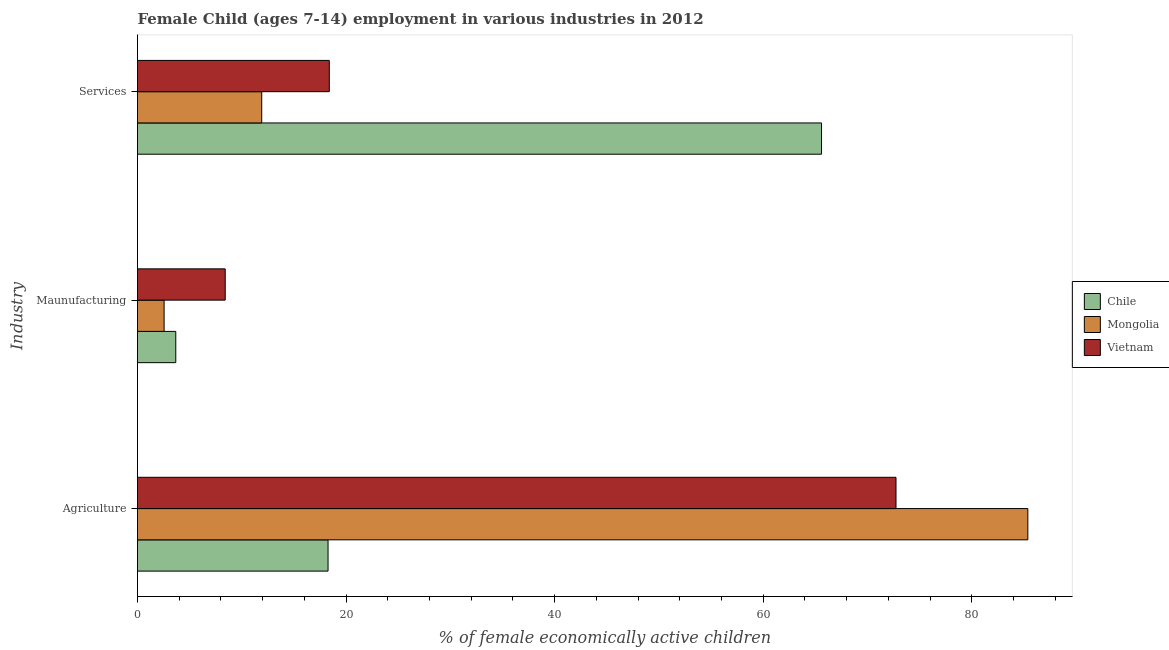How many groups of bars are there?
Offer a terse response. 3. Are the number of bars per tick equal to the number of legend labels?
Your response must be concise. Yes. Are the number of bars on each tick of the Y-axis equal?
Offer a terse response. Yes. What is the label of the 1st group of bars from the top?
Provide a short and direct response. Services. What is the percentage of economically active children in agriculture in Vietnam?
Provide a short and direct response. 72.73. Across all countries, what is the maximum percentage of economically active children in services?
Give a very brief answer. 65.59. Across all countries, what is the minimum percentage of economically active children in services?
Provide a succinct answer. 11.91. In which country was the percentage of economically active children in agriculture maximum?
Offer a terse response. Mongolia. In which country was the percentage of economically active children in services minimum?
Keep it short and to the point. Mongolia. What is the total percentage of economically active children in agriculture in the graph?
Keep it short and to the point. 176.37. What is the difference between the percentage of economically active children in services in Vietnam and that in Chile?
Keep it short and to the point. -47.2. What is the difference between the percentage of economically active children in manufacturing in Mongolia and the percentage of economically active children in services in Chile?
Your response must be concise. -63.04. What is the average percentage of economically active children in agriculture per country?
Your answer should be compact. 58.79. What is the difference between the percentage of economically active children in agriculture and percentage of economically active children in manufacturing in Vietnam?
Your answer should be very brief. 64.32. In how many countries, is the percentage of economically active children in agriculture greater than 44 %?
Ensure brevity in your answer.  2. What is the ratio of the percentage of economically active children in manufacturing in Vietnam to that in Mongolia?
Offer a terse response. 3.3. Is the difference between the percentage of economically active children in manufacturing in Mongolia and Vietnam greater than the difference between the percentage of economically active children in services in Mongolia and Vietnam?
Give a very brief answer. Yes. What is the difference between the highest and the second highest percentage of economically active children in services?
Keep it short and to the point. 47.2. What is the difference between the highest and the lowest percentage of economically active children in manufacturing?
Ensure brevity in your answer.  5.86. What does the 1st bar from the top in Maunufacturing represents?
Give a very brief answer. Vietnam. What does the 3rd bar from the bottom in Maunufacturing represents?
Make the answer very short. Vietnam. Is it the case that in every country, the sum of the percentage of economically active children in agriculture and percentage of economically active children in manufacturing is greater than the percentage of economically active children in services?
Offer a terse response. No. How many bars are there?
Make the answer very short. 9. Are all the bars in the graph horizontal?
Provide a short and direct response. Yes. Are the values on the major ticks of X-axis written in scientific E-notation?
Ensure brevity in your answer.  No. How many legend labels are there?
Provide a short and direct response. 3. How are the legend labels stacked?
Offer a terse response. Vertical. What is the title of the graph?
Your answer should be compact. Female Child (ages 7-14) employment in various industries in 2012. Does "Arab World" appear as one of the legend labels in the graph?
Your answer should be compact. No. What is the label or title of the X-axis?
Offer a terse response. % of female economically active children. What is the label or title of the Y-axis?
Your answer should be very brief. Industry. What is the % of female economically active children of Chile in Agriculture?
Your answer should be very brief. 18.27. What is the % of female economically active children of Mongolia in Agriculture?
Provide a short and direct response. 85.37. What is the % of female economically active children in Vietnam in Agriculture?
Provide a succinct answer. 72.73. What is the % of female economically active children in Chile in Maunufacturing?
Your response must be concise. 3.67. What is the % of female economically active children in Mongolia in Maunufacturing?
Ensure brevity in your answer.  2.55. What is the % of female economically active children in Vietnam in Maunufacturing?
Provide a short and direct response. 8.41. What is the % of female economically active children in Chile in Services?
Your response must be concise. 65.59. What is the % of female economically active children of Mongolia in Services?
Give a very brief answer. 11.91. What is the % of female economically active children of Vietnam in Services?
Your answer should be very brief. 18.39. Across all Industry, what is the maximum % of female economically active children of Chile?
Ensure brevity in your answer.  65.59. Across all Industry, what is the maximum % of female economically active children in Mongolia?
Offer a very short reply. 85.37. Across all Industry, what is the maximum % of female economically active children of Vietnam?
Your answer should be very brief. 72.73. Across all Industry, what is the minimum % of female economically active children of Chile?
Offer a terse response. 3.67. Across all Industry, what is the minimum % of female economically active children in Mongolia?
Give a very brief answer. 2.55. Across all Industry, what is the minimum % of female economically active children in Vietnam?
Make the answer very short. 8.41. What is the total % of female economically active children of Chile in the graph?
Your answer should be very brief. 87.53. What is the total % of female economically active children in Mongolia in the graph?
Your answer should be compact. 99.83. What is the total % of female economically active children of Vietnam in the graph?
Your answer should be compact. 99.53. What is the difference between the % of female economically active children in Mongolia in Agriculture and that in Maunufacturing?
Ensure brevity in your answer.  82.82. What is the difference between the % of female economically active children in Vietnam in Agriculture and that in Maunufacturing?
Offer a very short reply. 64.32. What is the difference between the % of female economically active children in Chile in Agriculture and that in Services?
Offer a very short reply. -47.32. What is the difference between the % of female economically active children in Mongolia in Agriculture and that in Services?
Your answer should be compact. 73.46. What is the difference between the % of female economically active children of Vietnam in Agriculture and that in Services?
Your response must be concise. 54.34. What is the difference between the % of female economically active children of Chile in Maunufacturing and that in Services?
Keep it short and to the point. -61.92. What is the difference between the % of female economically active children in Mongolia in Maunufacturing and that in Services?
Offer a very short reply. -9.36. What is the difference between the % of female economically active children of Vietnam in Maunufacturing and that in Services?
Make the answer very short. -9.98. What is the difference between the % of female economically active children in Chile in Agriculture and the % of female economically active children in Mongolia in Maunufacturing?
Provide a short and direct response. 15.72. What is the difference between the % of female economically active children of Chile in Agriculture and the % of female economically active children of Vietnam in Maunufacturing?
Provide a short and direct response. 9.86. What is the difference between the % of female economically active children of Mongolia in Agriculture and the % of female economically active children of Vietnam in Maunufacturing?
Provide a short and direct response. 76.96. What is the difference between the % of female economically active children in Chile in Agriculture and the % of female economically active children in Mongolia in Services?
Ensure brevity in your answer.  6.36. What is the difference between the % of female economically active children of Chile in Agriculture and the % of female economically active children of Vietnam in Services?
Keep it short and to the point. -0.12. What is the difference between the % of female economically active children of Mongolia in Agriculture and the % of female economically active children of Vietnam in Services?
Your answer should be compact. 66.98. What is the difference between the % of female economically active children in Chile in Maunufacturing and the % of female economically active children in Mongolia in Services?
Provide a short and direct response. -8.24. What is the difference between the % of female economically active children of Chile in Maunufacturing and the % of female economically active children of Vietnam in Services?
Provide a short and direct response. -14.72. What is the difference between the % of female economically active children in Mongolia in Maunufacturing and the % of female economically active children in Vietnam in Services?
Your response must be concise. -15.84. What is the average % of female economically active children of Chile per Industry?
Offer a terse response. 29.18. What is the average % of female economically active children of Mongolia per Industry?
Offer a very short reply. 33.28. What is the average % of female economically active children of Vietnam per Industry?
Provide a short and direct response. 33.18. What is the difference between the % of female economically active children of Chile and % of female economically active children of Mongolia in Agriculture?
Your answer should be very brief. -67.1. What is the difference between the % of female economically active children of Chile and % of female economically active children of Vietnam in Agriculture?
Your answer should be compact. -54.46. What is the difference between the % of female economically active children of Mongolia and % of female economically active children of Vietnam in Agriculture?
Ensure brevity in your answer.  12.64. What is the difference between the % of female economically active children of Chile and % of female economically active children of Mongolia in Maunufacturing?
Provide a short and direct response. 1.12. What is the difference between the % of female economically active children of Chile and % of female economically active children of Vietnam in Maunufacturing?
Offer a terse response. -4.74. What is the difference between the % of female economically active children in Mongolia and % of female economically active children in Vietnam in Maunufacturing?
Your response must be concise. -5.86. What is the difference between the % of female economically active children in Chile and % of female economically active children in Mongolia in Services?
Make the answer very short. 53.68. What is the difference between the % of female economically active children of Chile and % of female economically active children of Vietnam in Services?
Your answer should be compact. 47.2. What is the difference between the % of female economically active children of Mongolia and % of female economically active children of Vietnam in Services?
Give a very brief answer. -6.48. What is the ratio of the % of female economically active children in Chile in Agriculture to that in Maunufacturing?
Offer a very short reply. 4.98. What is the ratio of the % of female economically active children in Mongolia in Agriculture to that in Maunufacturing?
Provide a succinct answer. 33.48. What is the ratio of the % of female economically active children in Vietnam in Agriculture to that in Maunufacturing?
Offer a very short reply. 8.65. What is the ratio of the % of female economically active children of Chile in Agriculture to that in Services?
Your response must be concise. 0.28. What is the ratio of the % of female economically active children of Mongolia in Agriculture to that in Services?
Offer a terse response. 7.17. What is the ratio of the % of female economically active children in Vietnam in Agriculture to that in Services?
Make the answer very short. 3.95. What is the ratio of the % of female economically active children of Chile in Maunufacturing to that in Services?
Your answer should be compact. 0.06. What is the ratio of the % of female economically active children in Mongolia in Maunufacturing to that in Services?
Your response must be concise. 0.21. What is the ratio of the % of female economically active children in Vietnam in Maunufacturing to that in Services?
Offer a terse response. 0.46. What is the difference between the highest and the second highest % of female economically active children in Chile?
Keep it short and to the point. 47.32. What is the difference between the highest and the second highest % of female economically active children of Mongolia?
Your answer should be compact. 73.46. What is the difference between the highest and the second highest % of female economically active children of Vietnam?
Offer a terse response. 54.34. What is the difference between the highest and the lowest % of female economically active children of Chile?
Your answer should be very brief. 61.92. What is the difference between the highest and the lowest % of female economically active children of Mongolia?
Your answer should be very brief. 82.82. What is the difference between the highest and the lowest % of female economically active children of Vietnam?
Your answer should be compact. 64.32. 